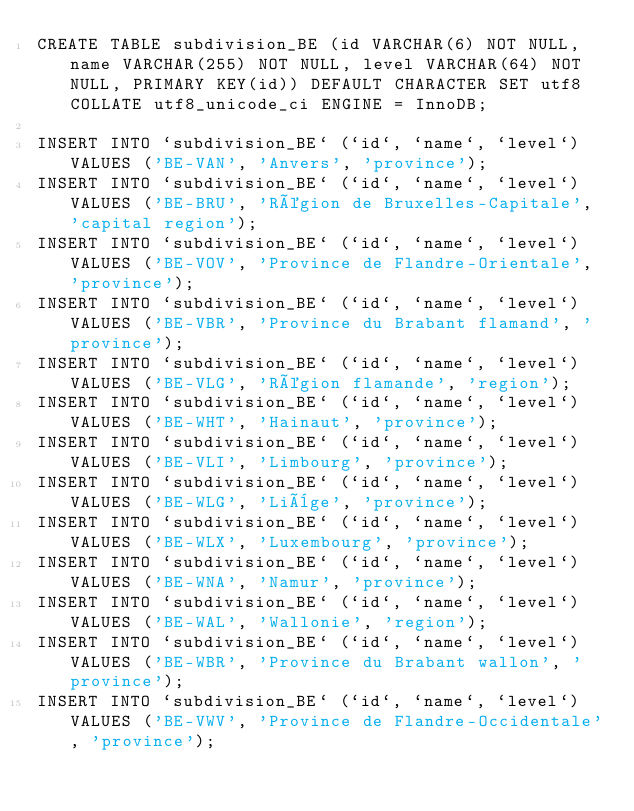<code> <loc_0><loc_0><loc_500><loc_500><_SQL_>CREATE TABLE subdivision_BE (id VARCHAR(6) NOT NULL, name VARCHAR(255) NOT NULL, level VARCHAR(64) NOT NULL, PRIMARY KEY(id)) DEFAULT CHARACTER SET utf8 COLLATE utf8_unicode_ci ENGINE = InnoDB;

INSERT INTO `subdivision_BE` (`id`, `name`, `level`) VALUES ('BE-VAN', 'Anvers', 'province');
INSERT INTO `subdivision_BE` (`id`, `name`, `level`) VALUES ('BE-BRU', 'Région de Bruxelles-Capitale', 'capital region');
INSERT INTO `subdivision_BE` (`id`, `name`, `level`) VALUES ('BE-VOV', 'Province de Flandre-Orientale', 'province');
INSERT INTO `subdivision_BE` (`id`, `name`, `level`) VALUES ('BE-VBR', 'Province du Brabant flamand', 'province');
INSERT INTO `subdivision_BE` (`id`, `name`, `level`) VALUES ('BE-VLG', 'Région flamande', 'region');
INSERT INTO `subdivision_BE` (`id`, `name`, `level`) VALUES ('BE-WHT', 'Hainaut', 'province');
INSERT INTO `subdivision_BE` (`id`, `name`, `level`) VALUES ('BE-VLI', 'Limbourg', 'province');
INSERT INTO `subdivision_BE` (`id`, `name`, `level`) VALUES ('BE-WLG', 'Liège', 'province');
INSERT INTO `subdivision_BE` (`id`, `name`, `level`) VALUES ('BE-WLX', 'Luxembourg', 'province');
INSERT INTO `subdivision_BE` (`id`, `name`, `level`) VALUES ('BE-WNA', 'Namur', 'province');
INSERT INTO `subdivision_BE` (`id`, `name`, `level`) VALUES ('BE-WAL', 'Wallonie', 'region');
INSERT INTO `subdivision_BE` (`id`, `name`, `level`) VALUES ('BE-WBR', 'Province du Brabant wallon', 'province');
INSERT INTO `subdivision_BE` (`id`, `name`, `level`) VALUES ('BE-VWV', 'Province de Flandre-Occidentale', 'province');
</code> 